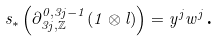Convert formula to latex. <formula><loc_0><loc_0><loc_500><loc_500>s _ { \ast } \left ( \partial _ { 3 j , \mathbb { \mathbb { Z } } } ^ { 0 , 3 j - 1 } ( 1 \otimes l ) \right ) = y ^ { j } w ^ { j } \text {.}</formula> 